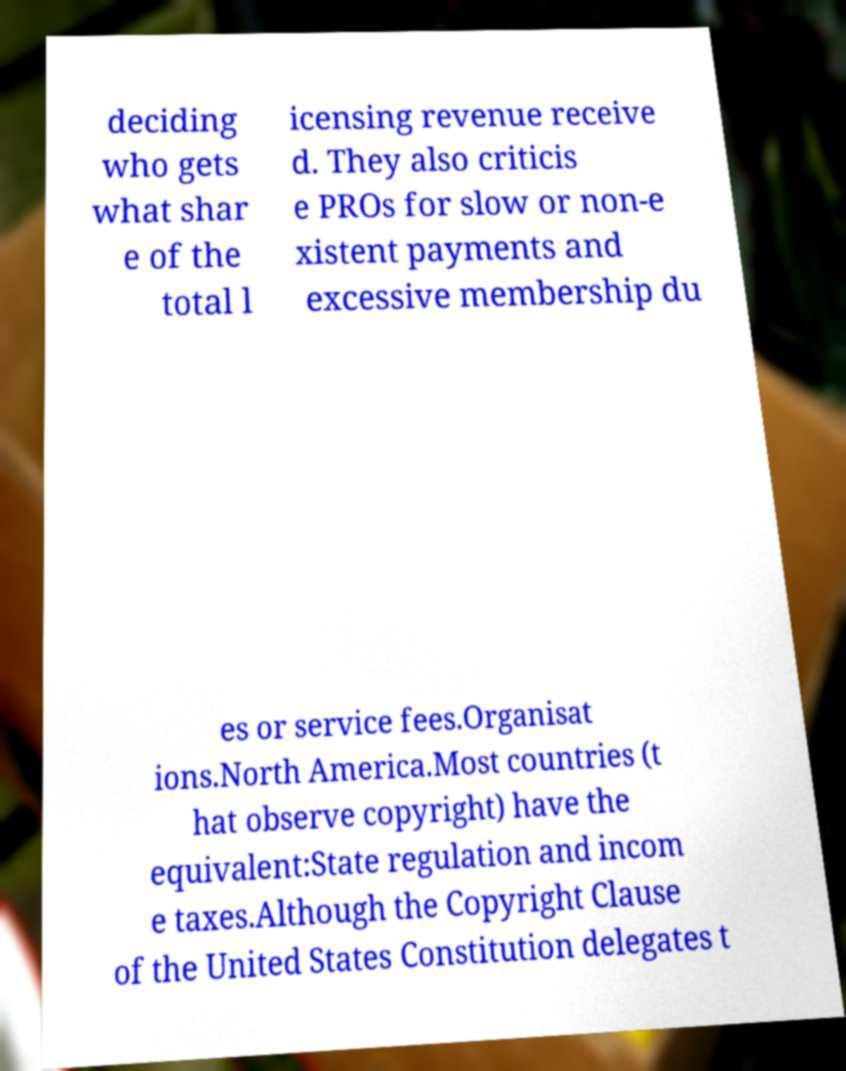For documentation purposes, I need the text within this image transcribed. Could you provide that? deciding who gets what shar e of the total l icensing revenue receive d. They also criticis e PROs for slow or non-e xistent payments and excessive membership du es or service fees.Organisat ions.North America.Most countries (t hat observe copyright) have the equivalent:State regulation and incom e taxes.Although the Copyright Clause of the United States Constitution delegates t 